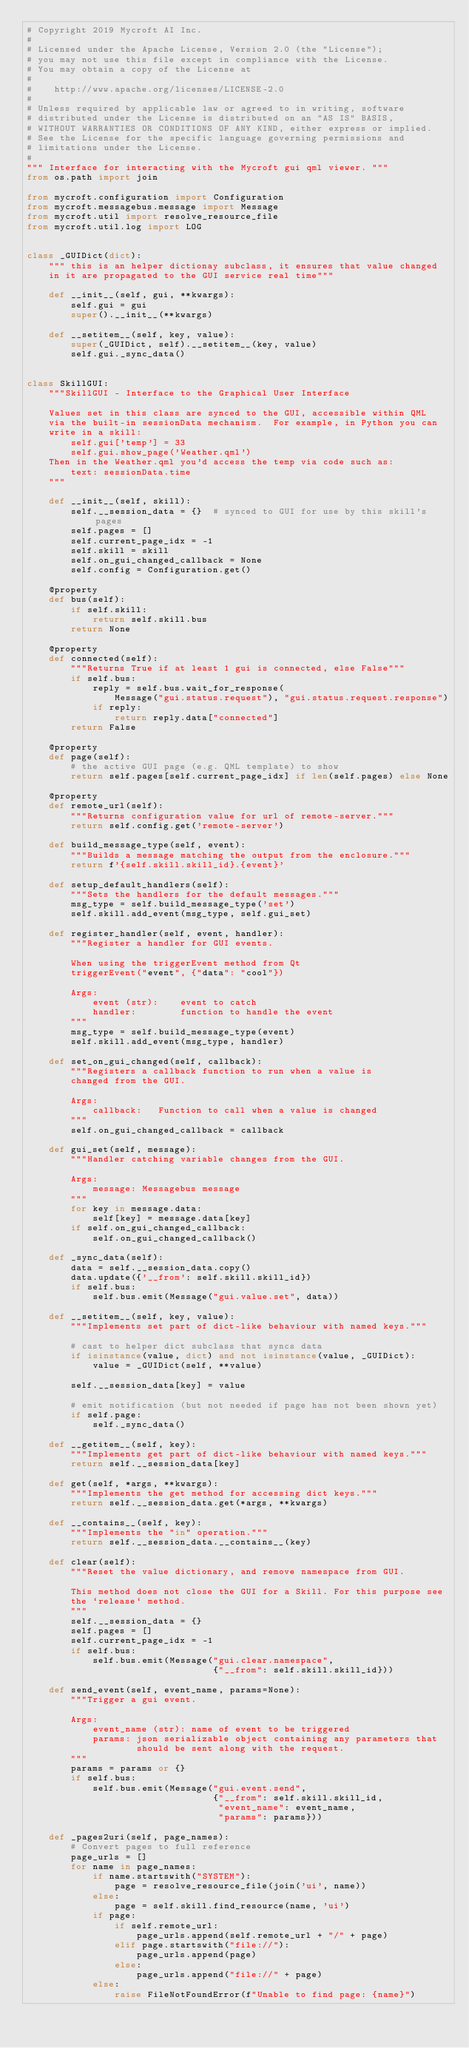<code> <loc_0><loc_0><loc_500><loc_500><_Python_># Copyright 2019 Mycroft AI Inc.
#
# Licensed under the Apache License, Version 2.0 (the "License");
# you may not use this file except in compliance with the License.
# You may obtain a copy of the License at
#
#    http://www.apache.org/licenses/LICENSE-2.0
#
# Unless required by applicable law or agreed to in writing, software
# distributed under the License is distributed on an "AS IS" BASIS,
# WITHOUT WARRANTIES OR CONDITIONS OF ANY KIND, either express or implied.
# See the License for the specific language governing permissions and
# limitations under the License.
#
""" Interface for interacting with the Mycroft gui qml viewer. """
from os.path import join

from mycroft.configuration import Configuration
from mycroft.messagebus.message import Message
from mycroft.util import resolve_resource_file
from mycroft.util.log import LOG


class _GUIDict(dict):
    """ this is an helper dictionay subclass, it ensures that value changed
    in it are propagated to the GUI service real time"""

    def __init__(self, gui, **kwargs):
        self.gui = gui
        super().__init__(**kwargs)

    def __setitem__(self, key, value):
        super(_GUIDict, self).__setitem__(key, value)
        self.gui._sync_data()


class SkillGUI:
    """SkillGUI - Interface to the Graphical User Interface

    Values set in this class are synced to the GUI, accessible within QML
    via the built-in sessionData mechanism.  For example, in Python you can
    write in a skill:
        self.gui['temp'] = 33
        self.gui.show_page('Weather.qml')
    Then in the Weather.qml you'd access the temp via code such as:
        text: sessionData.time
    """

    def __init__(self, skill):
        self.__session_data = {}  # synced to GUI for use by this skill's pages
        self.pages = []
        self.current_page_idx = -1
        self.skill = skill
        self.on_gui_changed_callback = None
        self.config = Configuration.get()

    @property
    def bus(self):
        if self.skill:
            return self.skill.bus
        return None

    @property
    def connected(self):
        """Returns True if at least 1 gui is connected, else False"""
        if self.bus:
            reply = self.bus.wait_for_response(
                Message("gui.status.request"), "gui.status.request.response")
            if reply:
                return reply.data["connected"]
        return False

    @property
    def page(self):
        # the active GUI page (e.g. QML template) to show
        return self.pages[self.current_page_idx] if len(self.pages) else None

    @property
    def remote_url(self):
        """Returns configuration value for url of remote-server."""
        return self.config.get('remote-server')

    def build_message_type(self, event):
        """Builds a message matching the output from the enclosure."""
        return f'{self.skill.skill_id}.{event}'

    def setup_default_handlers(self):
        """Sets the handlers for the default messages."""
        msg_type = self.build_message_type('set')
        self.skill.add_event(msg_type, self.gui_set)

    def register_handler(self, event, handler):
        """Register a handler for GUI events.

        When using the triggerEvent method from Qt
        triggerEvent("event", {"data": "cool"})

        Args:
            event (str):    event to catch
            handler:        function to handle the event
        """
        msg_type = self.build_message_type(event)
        self.skill.add_event(msg_type, handler)

    def set_on_gui_changed(self, callback):
        """Registers a callback function to run when a value is
        changed from the GUI.

        Args:
            callback:   Function to call when a value is changed
        """
        self.on_gui_changed_callback = callback

    def gui_set(self, message):
        """Handler catching variable changes from the GUI.

        Args:
            message: Messagebus message
        """
        for key in message.data:
            self[key] = message.data[key]
        if self.on_gui_changed_callback:
            self.on_gui_changed_callback()

    def _sync_data(self):
        data = self.__session_data.copy()
        data.update({'__from': self.skill.skill_id})
        if self.bus:
            self.bus.emit(Message("gui.value.set", data))

    def __setitem__(self, key, value):
        """Implements set part of dict-like behaviour with named keys."""

        # cast to helper dict subclass that syncs data
        if isinstance(value, dict) and not isinstance(value, _GUIDict):
            value = _GUIDict(self, **value)

        self.__session_data[key] = value

        # emit notification (but not needed if page has not been shown yet)
        if self.page:
            self._sync_data()

    def __getitem__(self, key):
        """Implements get part of dict-like behaviour with named keys."""
        return self.__session_data[key]

    def get(self, *args, **kwargs):
        """Implements the get method for accessing dict keys."""
        return self.__session_data.get(*args, **kwargs)

    def __contains__(self, key):
        """Implements the "in" operation."""
        return self.__session_data.__contains__(key)

    def clear(self):
        """Reset the value dictionary, and remove namespace from GUI.

        This method does not close the GUI for a Skill. For this purpose see
        the `release` method.
        """
        self.__session_data = {}
        self.pages = []
        self.current_page_idx = -1
        if self.bus:
            self.bus.emit(Message("gui.clear.namespace",
                                  {"__from": self.skill.skill_id}))

    def send_event(self, event_name, params=None):
        """Trigger a gui event.

        Args:
            event_name (str): name of event to be triggered
            params: json serializable object containing any parameters that
                    should be sent along with the request.
        """
        params = params or {}
        if self.bus:
            self.bus.emit(Message("gui.event.send",
                                  {"__from": self.skill.skill_id,
                                   "event_name": event_name,
                                   "params": params}))

    def _pages2uri(self, page_names):
        # Convert pages to full reference
        page_urls = []
        for name in page_names:
            if name.startswith("SYSTEM"):
                page = resolve_resource_file(join('ui', name))
            else:
                page = self.skill.find_resource(name, 'ui')
            if page:
                if self.remote_url:
                    page_urls.append(self.remote_url + "/" + page)
                elif page.startswith("file://"):
                    page_urls.append(page)
                else:
                    page_urls.append("file://" + page)
            else:
                raise FileNotFoundError(f"Unable to find page: {name}")
</code> 